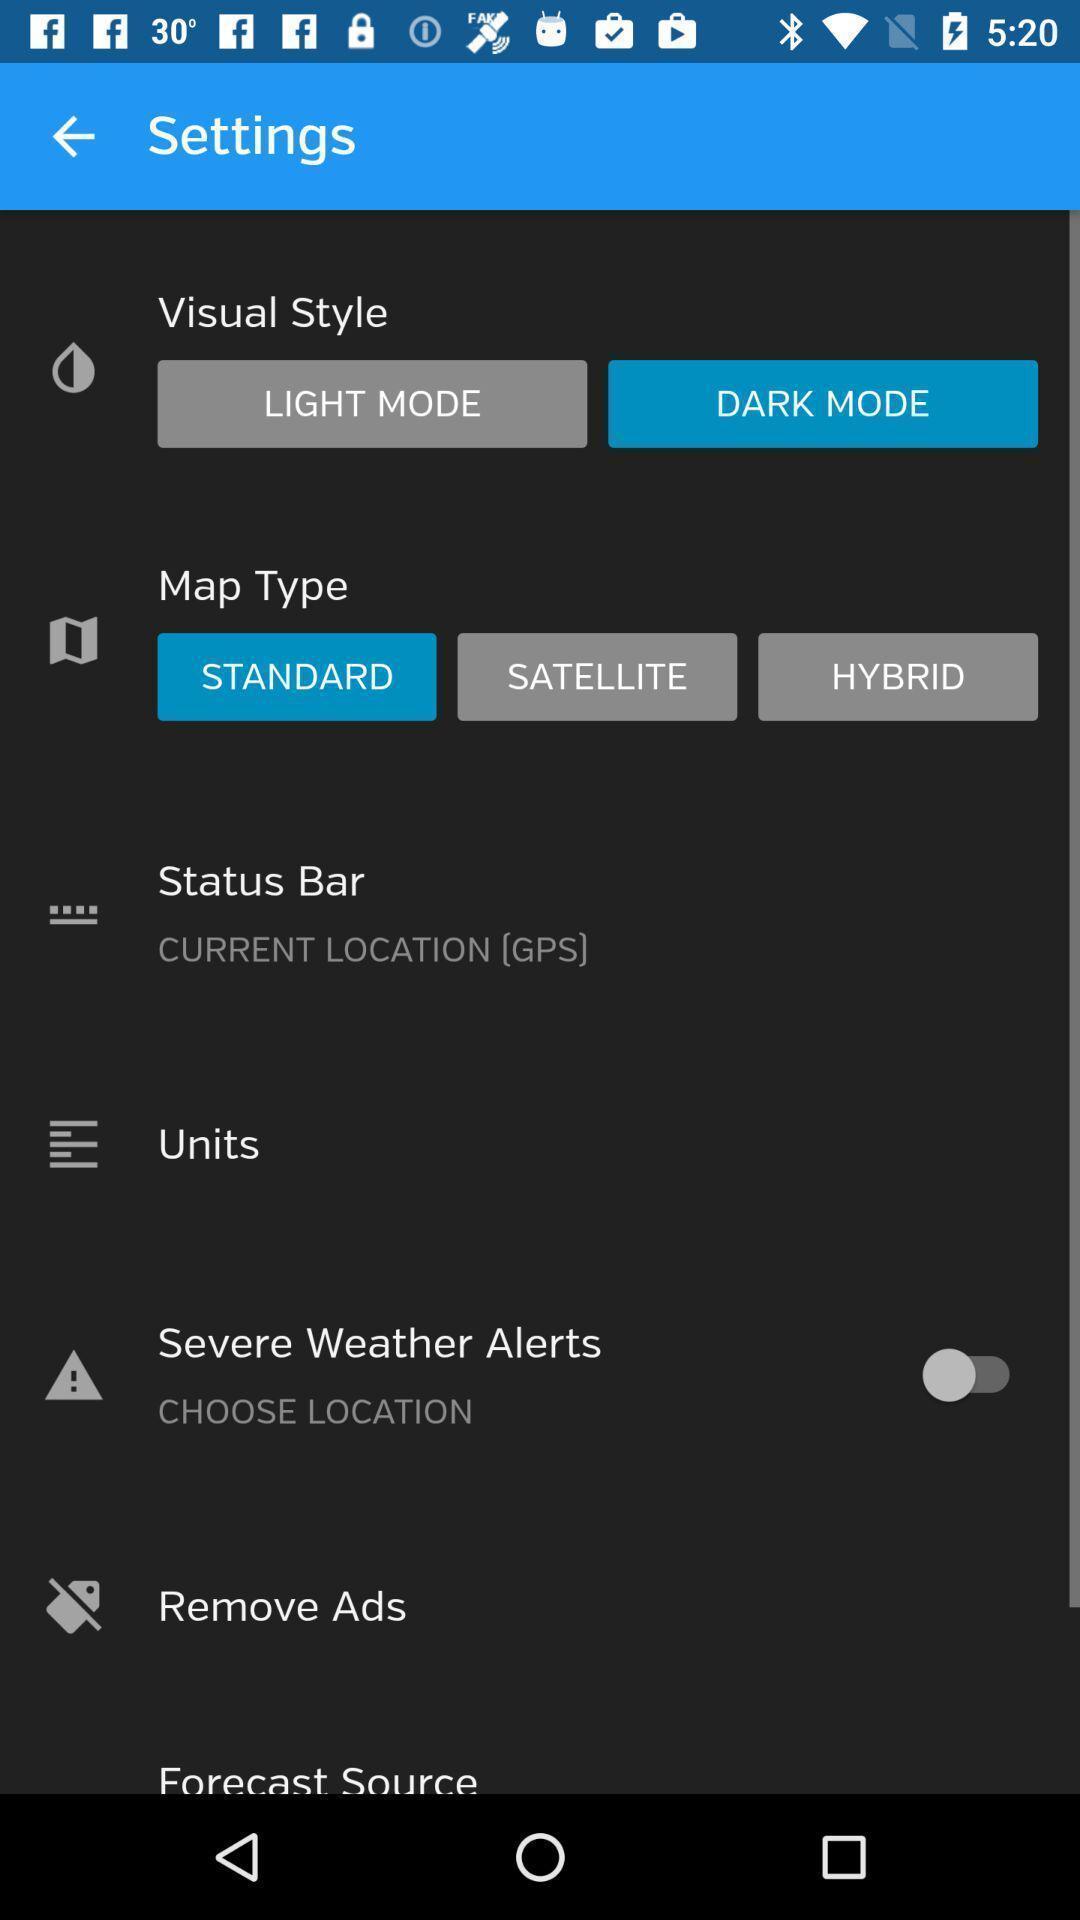Describe this image in words. Settings page with different options in the mapping app. 